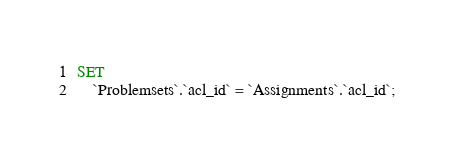<code> <loc_0><loc_0><loc_500><loc_500><_SQL_>SET
    `Problemsets`.`acl_id` = `Assignments`.`acl_id`;</code> 